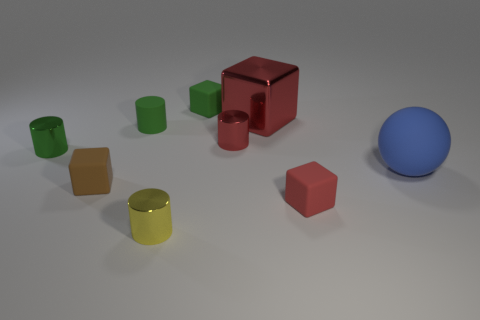What number of cylinders are small yellow shiny objects or big things?
Give a very brief answer. 1. There is a rubber ball on the right side of the small green rubber object that is in front of the large red shiny thing; are there any large blue objects on the left side of it?
Give a very brief answer. No. There is a shiny thing that is the same shape as the red matte thing; what is its color?
Your answer should be compact. Red. What number of blue things are either tiny rubber cubes or small objects?
Give a very brief answer. 0. The tiny object right of the red metal thing on the left side of the large red metal cube is made of what material?
Your response must be concise. Rubber. Is the shape of the brown matte thing the same as the blue object?
Provide a short and direct response. No. There is a matte cylinder that is the same size as the yellow thing; what color is it?
Make the answer very short. Green. Are there any rubber blocks that have the same color as the shiny block?
Your response must be concise. Yes. Are there any blue balls?
Your answer should be compact. Yes. Are the small red thing behind the small red cube and the small yellow thing made of the same material?
Provide a succinct answer. Yes. 